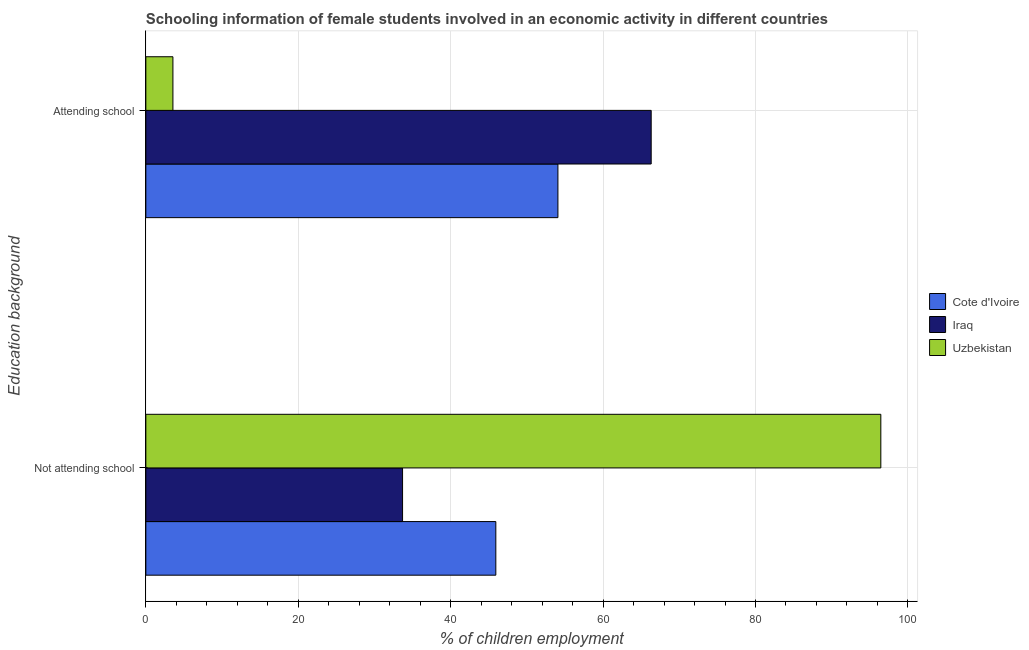How many groups of bars are there?
Keep it short and to the point. 2. Are the number of bars per tick equal to the number of legend labels?
Give a very brief answer. Yes. What is the label of the 1st group of bars from the top?
Give a very brief answer. Attending school. What is the percentage of employed females who are not attending school in Cote d'Ivoire?
Provide a succinct answer. 45.93. Across all countries, what is the maximum percentage of employed females who are attending school?
Ensure brevity in your answer.  66.31. Across all countries, what is the minimum percentage of employed females who are attending school?
Provide a succinct answer. 3.55. In which country was the percentage of employed females who are not attending school maximum?
Provide a short and direct response. Uzbekistan. In which country was the percentage of employed females who are attending school minimum?
Offer a very short reply. Uzbekistan. What is the total percentage of employed females who are attending school in the graph?
Ensure brevity in your answer.  123.94. What is the difference between the percentage of employed females who are attending school in Cote d'Ivoire and that in Uzbekistan?
Ensure brevity in your answer.  50.52. What is the difference between the percentage of employed females who are attending school in Cote d'Ivoire and the percentage of employed females who are not attending school in Iraq?
Your answer should be very brief. 20.39. What is the average percentage of employed females who are not attending school per country?
Make the answer very short. 58.69. What is the difference between the percentage of employed females who are attending school and percentage of employed females who are not attending school in Iraq?
Your answer should be compact. 32.63. In how many countries, is the percentage of employed females who are not attending school greater than 96 %?
Keep it short and to the point. 1. What is the ratio of the percentage of employed females who are attending school in Iraq to that in Uzbekistan?
Your response must be concise. 18.66. In how many countries, is the percentage of employed females who are not attending school greater than the average percentage of employed females who are not attending school taken over all countries?
Make the answer very short. 1. What does the 3rd bar from the top in Attending school represents?
Provide a short and direct response. Cote d'Ivoire. What does the 3rd bar from the bottom in Not attending school represents?
Make the answer very short. Uzbekistan. How many countries are there in the graph?
Your response must be concise. 3. What is the difference between two consecutive major ticks on the X-axis?
Your response must be concise. 20. Does the graph contain any zero values?
Your answer should be very brief. No. Where does the legend appear in the graph?
Your response must be concise. Center right. How many legend labels are there?
Your answer should be compact. 3. What is the title of the graph?
Provide a succinct answer. Schooling information of female students involved in an economic activity in different countries. Does "Vietnam" appear as one of the legend labels in the graph?
Your answer should be very brief. No. What is the label or title of the X-axis?
Keep it short and to the point. % of children employment. What is the label or title of the Y-axis?
Give a very brief answer. Education background. What is the % of children employment of Cote d'Ivoire in Not attending school?
Your answer should be compact. 45.93. What is the % of children employment in Iraq in Not attending school?
Provide a short and direct response. 33.69. What is the % of children employment in Uzbekistan in Not attending school?
Your answer should be very brief. 96.45. What is the % of children employment in Cote d'Ivoire in Attending school?
Offer a very short reply. 54.07. What is the % of children employment in Iraq in Attending school?
Offer a terse response. 66.31. What is the % of children employment of Uzbekistan in Attending school?
Offer a very short reply. 3.55. Across all Education background, what is the maximum % of children employment in Cote d'Ivoire?
Your response must be concise. 54.07. Across all Education background, what is the maximum % of children employment of Iraq?
Make the answer very short. 66.31. Across all Education background, what is the maximum % of children employment of Uzbekistan?
Provide a succinct answer. 96.45. Across all Education background, what is the minimum % of children employment in Cote d'Ivoire?
Make the answer very short. 45.93. Across all Education background, what is the minimum % of children employment of Iraq?
Provide a short and direct response. 33.69. Across all Education background, what is the minimum % of children employment in Uzbekistan?
Offer a terse response. 3.55. What is the total % of children employment in Uzbekistan in the graph?
Give a very brief answer. 100. What is the difference between the % of children employment of Cote d'Ivoire in Not attending school and that in Attending school?
Offer a terse response. -8.15. What is the difference between the % of children employment of Iraq in Not attending school and that in Attending school?
Keep it short and to the point. -32.63. What is the difference between the % of children employment in Uzbekistan in Not attending school and that in Attending school?
Give a very brief answer. 92.89. What is the difference between the % of children employment in Cote d'Ivoire in Not attending school and the % of children employment in Iraq in Attending school?
Offer a very short reply. -20.39. What is the difference between the % of children employment of Cote d'Ivoire in Not attending school and the % of children employment of Uzbekistan in Attending school?
Offer a terse response. 42.37. What is the difference between the % of children employment in Iraq in Not attending school and the % of children employment in Uzbekistan in Attending school?
Give a very brief answer. 30.13. What is the average % of children employment of Iraq per Education background?
Make the answer very short. 50. What is the average % of children employment of Uzbekistan per Education background?
Offer a very short reply. 50. What is the difference between the % of children employment in Cote d'Ivoire and % of children employment in Iraq in Not attending school?
Ensure brevity in your answer.  12.24. What is the difference between the % of children employment of Cote d'Ivoire and % of children employment of Uzbekistan in Not attending school?
Provide a short and direct response. -50.52. What is the difference between the % of children employment of Iraq and % of children employment of Uzbekistan in Not attending school?
Your answer should be very brief. -62.76. What is the difference between the % of children employment of Cote d'Ivoire and % of children employment of Iraq in Attending school?
Your answer should be compact. -12.24. What is the difference between the % of children employment of Cote d'Ivoire and % of children employment of Uzbekistan in Attending school?
Ensure brevity in your answer.  50.52. What is the difference between the % of children employment in Iraq and % of children employment in Uzbekistan in Attending school?
Ensure brevity in your answer.  62.76. What is the ratio of the % of children employment in Cote d'Ivoire in Not attending school to that in Attending school?
Keep it short and to the point. 0.85. What is the ratio of the % of children employment in Iraq in Not attending school to that in Attending school?
Ensure brevity in your answer.  0.51. What is the ratio of the % of children employment of Uzbekistan in Not attending school to that in Attending school?
Your answer should be compact. 27.13. What is the difference between the highest and the second highest % of children employment in Cote d'Ivoire?
Your answer should be compact. 8.15. What is the difference between the highest and the second highest % of children employment in Iraq?
Offer a very short reply. 32.63. What is the difference between the highest and the second highest % of children employment of Uzbekistan?
Ensure brevity in your answer.  92.89. What is the difference between the highest and the lowest % of children employment of Cote d'Ivoire?
Provide a succinct answer. 8.15. What is the difference between the highest and the lowest % of children employment in Iraq?
Offer a terse response. 32.63. What is the difference between the highest and the lowest % of children employment of Uzbekistan?
Make the answer very short. 92.89. 